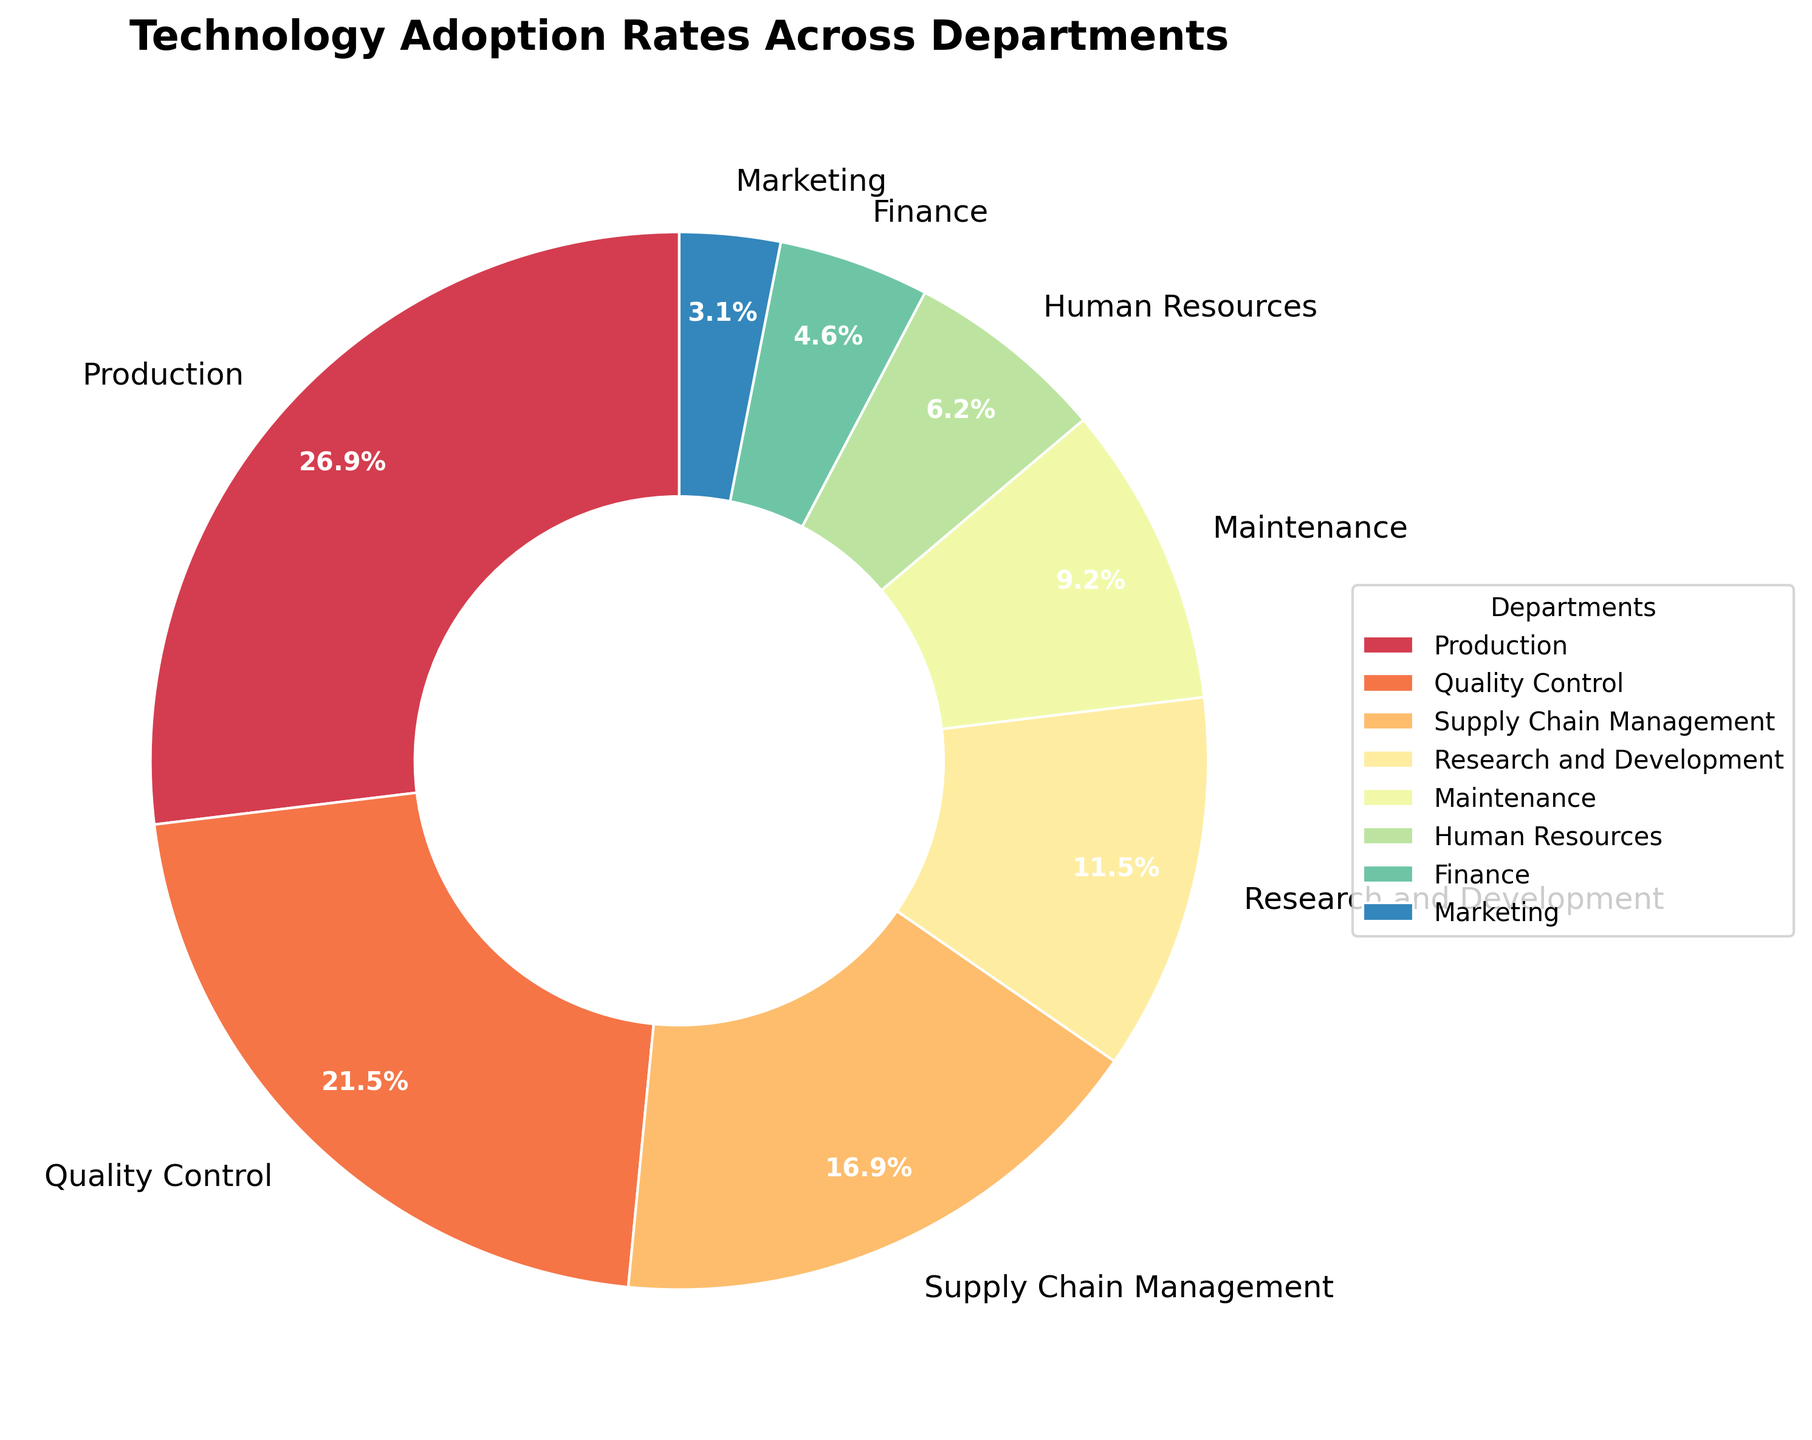What's the department with the highest technology adoption rate? The figure shows a pie chart that represents the technology adoption rates of various departments. The wedge with the largest area corresponds to the Production department, indicating it has the highest adoption rate.
Answer: Production What is the combined adoption rate of Production and Quality Control? From the pie chart, the adoption rate for Production is 35% and for Quality Control is 28%. Adding these two together gives 35 + 28 = 63%.
Answer: 63% Which departments have an adoption rate above 20%? The pie chart shows the adoption rates of various departments. Production has 35%, Quality Control has 28%, and Supply Chain Management has 22%. These are the only departments with rates above 20%.
Answer: Production, Quality Control, Supply Chain Management How does the adoption rate of Research and Development compare to that of Maintenance? The pie chart shows that the adoption rate for Research and Development is 15%, while Maintenance has a rate of 12%. Thus, Research and Development has a higher adoption rate than Maintenance.
Answer: Research and Development has a higher adoption rate What is the difference in adoption rate between the Finance and Marketing departments? According to the pie chart, Finance has an adoption rate of 6%, and Marketing has an adoption rate of 4%. The difference is calculated as 6 - 4 = 2%.
Answer: 2% What percentage of the total adoption rate is contributed by Human Resources, Finance, and Marketing combined? Human Resources has an 8% adoption rate, Finance has 6%, and Marketing has 4%. Adding these together gives 8 + 6 + 4 = 18%.
Answer: 18% Which departments have the smallest wedges in the pie chart? From the visual representation of the chart, the smallest wedges belong to the Marketing (4%), Finance (6%), and Human Resources (8%) departments.
Answer: Marketing, Finance, Human Resources What’s more prevalent, the adoption rate of Supply Chain Management or the combined rate of Finance and Marketing? The adoption rate for Supply Chain Management is 22%. The combined rate of Finance (6%) and Marketing (4%) is 6 + 4 = 10%. Therefore, Supply Chain Management has a higher adoption rate.
Answer: Supply Chain Management Which department's wedge would have the same visual size as combining Maintenance and Human Resources? Maintenance has an adoption rate of 12%, and Human Resources have 8%. Together, they sum up to 12 + 8 = 20%. The Supply Chain Management department also has an adoption rate close to this value at 22% and would theoretically have a similar wedge size.
Answer: Supply Chain Management 